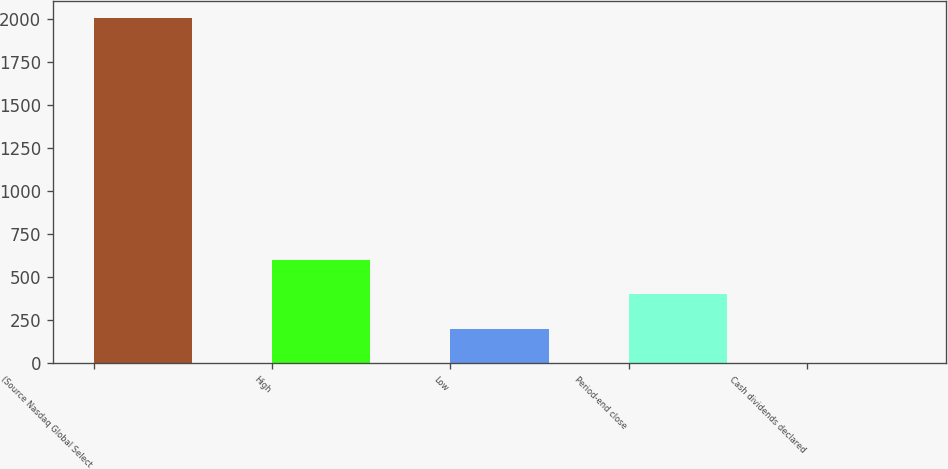Convert chart to OTSL. <chart><loc_0><loc_0><loc_500><loc_500><bar_chart><fcel>(Source Nasdaq Global Select<fcel>High<fcel>Low<fcel>Period-end close<fcel>Cash dividends declared<nl><fcel>2006<fcel>602.05<fcel>200.91<fcel>401.48<fcel>0.34<nl></chart> 